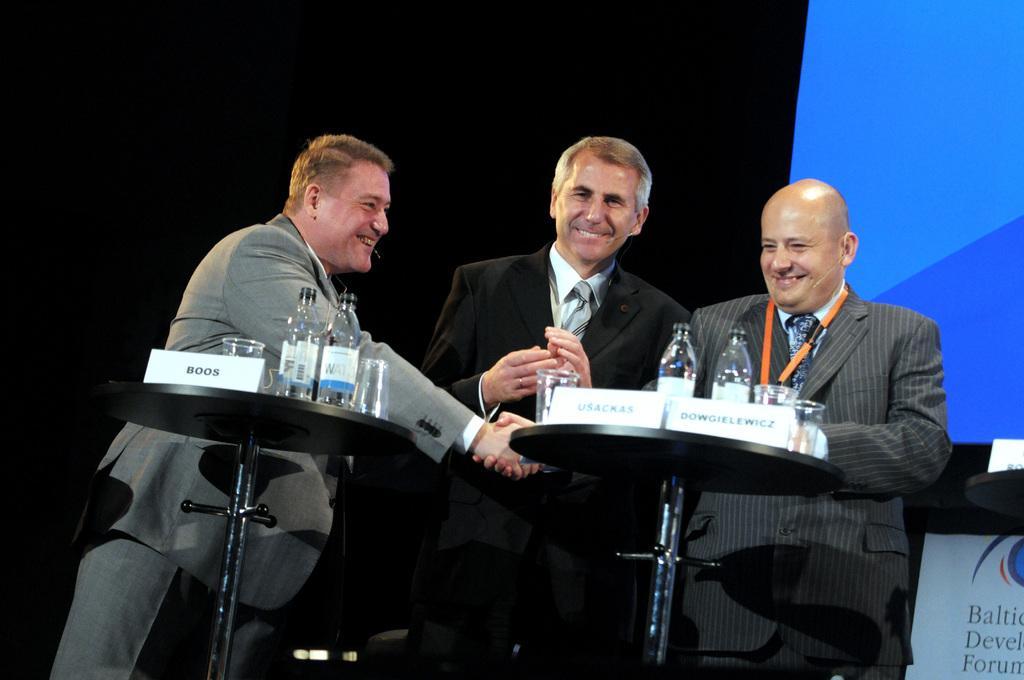Describe this image in one or two sentences. In the picture we can see three men are standing and they are in blazers, ties and shirts and one man is shaking hands with another man and near them, we can see two round tables on it, we can see some bottles and glasses and in the background we can see a black color surface with a part of the screen which is blue in color. 